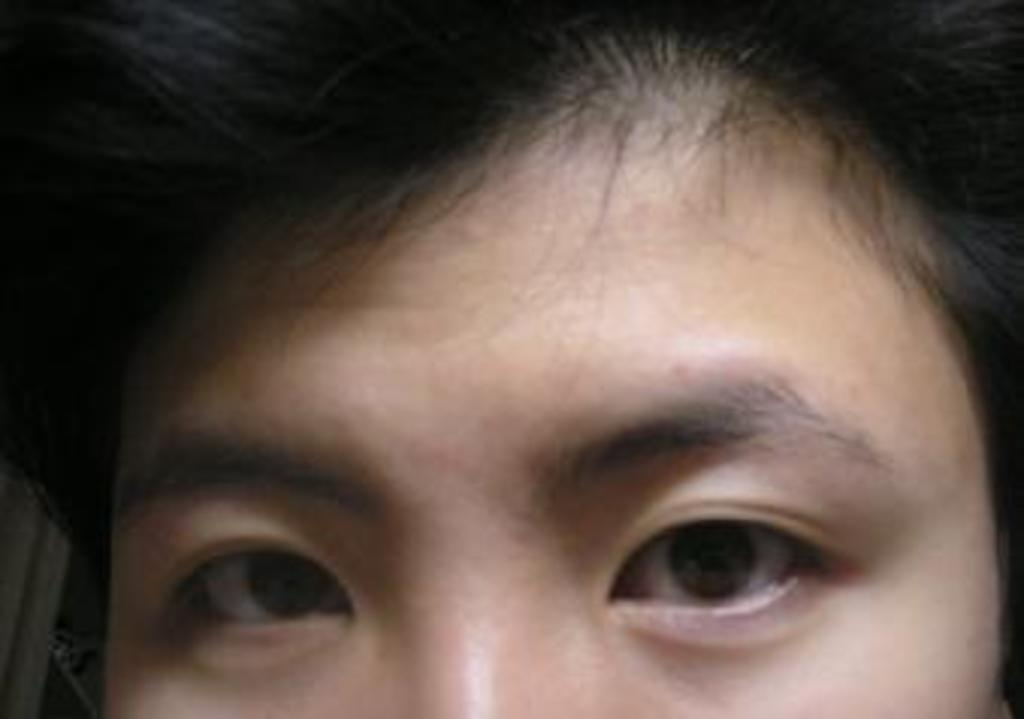What is the main subject of the image? There is a person's face in the image. What type of song is being played by the brain in the image? There is no brain or song present in the image; it only features a person's face. 